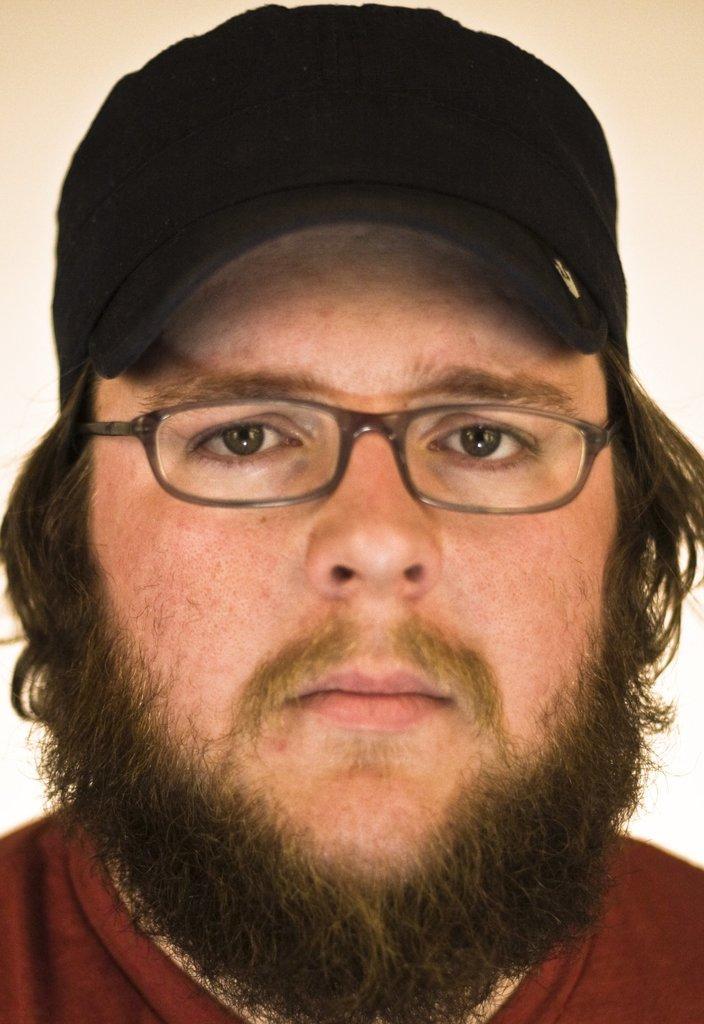Can you describe this image briefly? In this image we can see the head of a man. He is wearing a red color T-shirt. Here we can see a cap on his head. Here we can see the spectacles. 